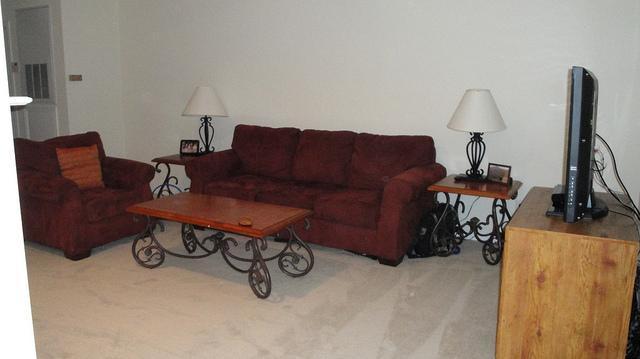How many lamps are pictured?
Give a very brief answer. 2. How many couches are there?
Give a very brief answer. 2. 